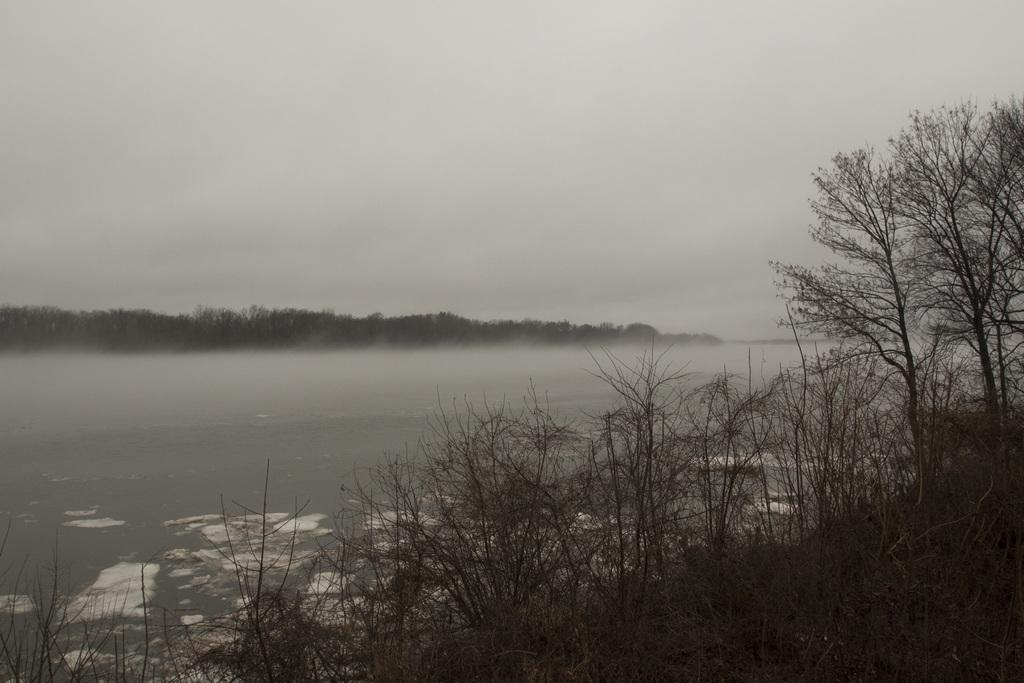What type of plants are at the bottom of the image? There are plants without leaves at the bottom of the image. What is visible behind the plants? There is water behind the plants. What can be seen in the distance in the image? There are trees in the background of the image. What color is the background of the image? The background of the image is white. What type of nerve is visible in the image? There is no nerve present in the image. What event is taking place in the image? The image does not depict an event; it shows plants, water, and trees. 